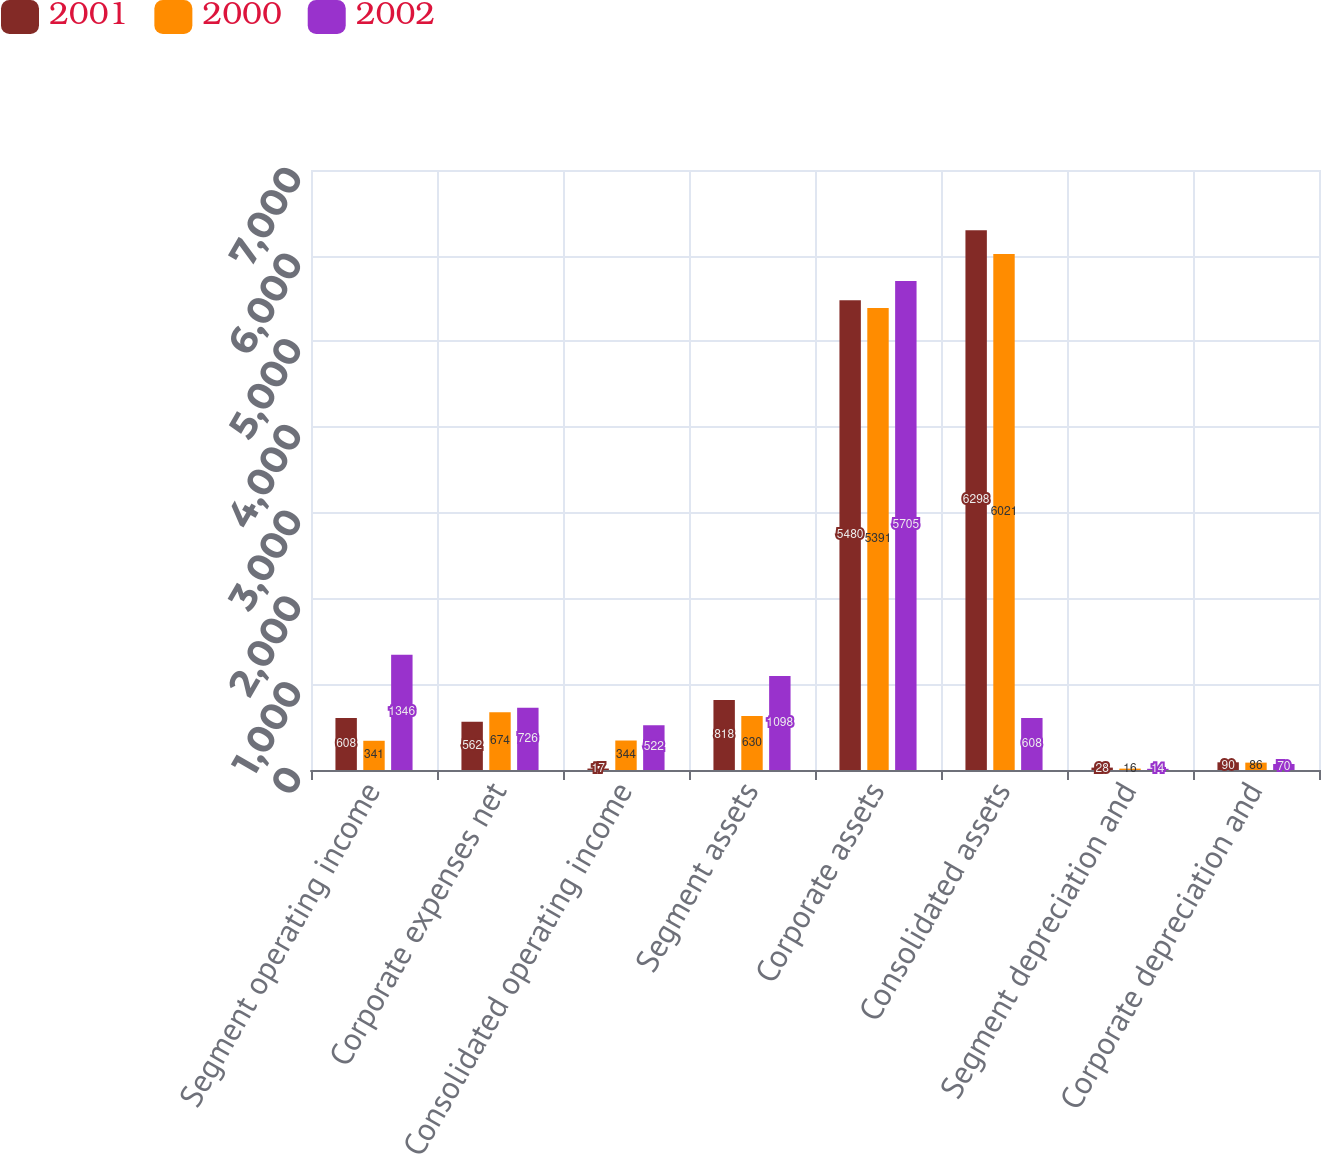<chart> <loc_0><loc_0><loc_500><loc_500><stacked_bar_chart><ecel><fcel>Segment operating income<fcel>Corporate expenses net<fcel>Consolidated operating income<fcel>Segment assets<fcel>Corporate assets<fcel>Consolidated assets<fcel>Segment depreciation and<fcel>Corporate depreciation and<nl><fcel>2001<fcel>608<fcel>562<fcel>17<fcel>818<fcel>5480<fcel>6298<fcel>28<fcel>90<nl><fcel>2000<fcel>341<fcel>674<fcel>344<fcel>630<fcel>5391<fcel>6021<fcel>16<fcel>86<nl><fcel>2002<fcel>1346<fcel>726<fcel>522<fcel>1098<fcel>5705<fcel>608<fcel>14<fcel>70<nl></chart> 